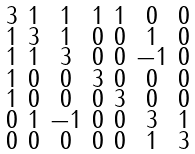Convert formula to latex. <formula><loc_0><loc_0><loc_500><loc_500>\begin{smallmatrix} 3 & 1 & 1 & 1 & 1 & 0 & 0 \\ 1 & 3 & 1 & 0 & 0 & 1 & 0 \\ 1 & 1 & 3 & 0 & 0 & - 1 & 0 \\ 1 & 0 & 0 & 3 & 0 & 0 & 0 \\ 1 & 0 & 0 & 0 & 3 & 0 & 0 \\ 0 & 1 & - 1 & 0 & 0 & 3 & 1 \\ 0 & 0 & 0 & 0 & 0 & 1 & 3 \end{smallmatrix}</formula> 